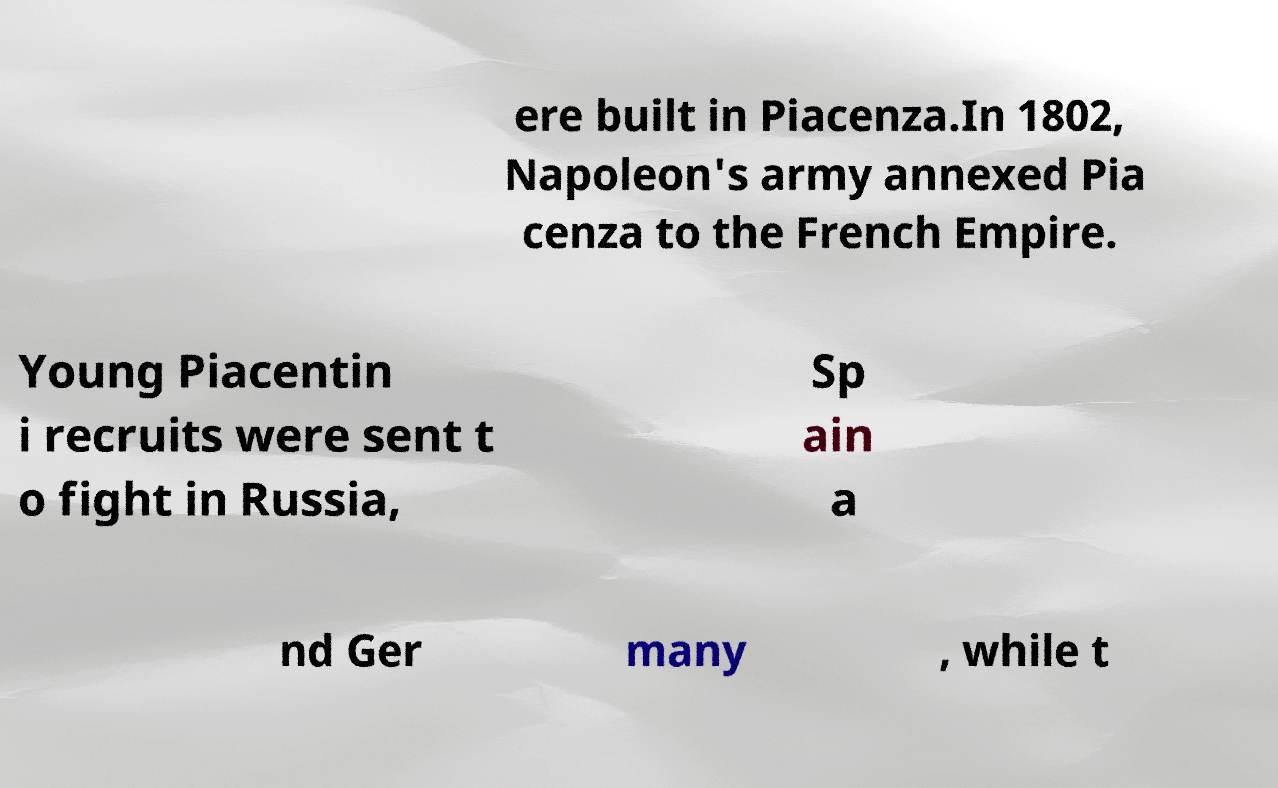Could you assist in decoding the text presented in this image and type it out clearly? ere built in Piacenza.In 1802, Napoleon's army annexed Pia cenza to the French Empire. Young Piacentin i recruits were sent t o fight in Russia, Sp ain a nd Ger many , while t 